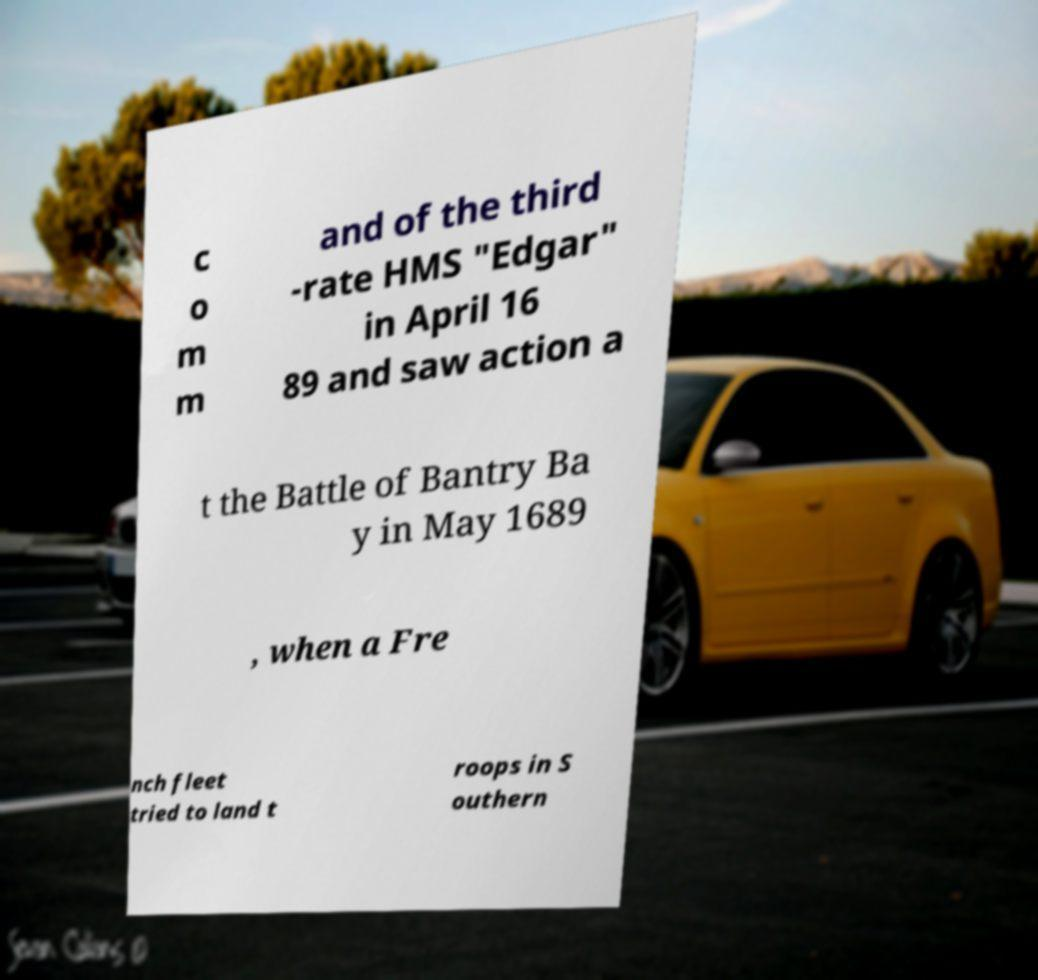Can you read and provide the text displayed in the image?This photo seems to have some interesting text. Can you extract and type it out for me? c o m m and of the third -rate HMS "Edgar" in April 16 89 and saw action a t the Battle of Bantry Ba y in May 1689 , when a Fre nch fleet tried to land t roops in S outhern 